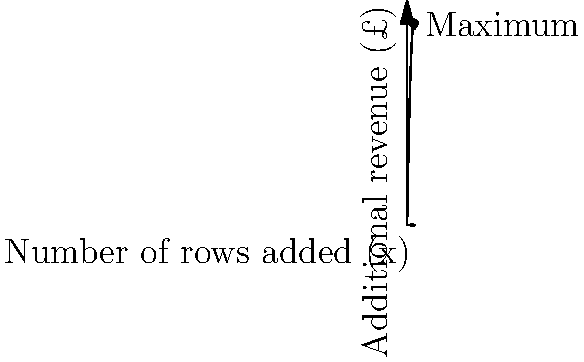Scone Thistle is planning to expand their stadium. The additional revenue (in £) generated by adding x rows of seats can be modeled by the function $R(x) = -0.5x^2 + 60x$. How many rows should be added to maximize the additional revenue, and what is this maximum revenue? To find the maximum revenue, we need to follow these steps:

1) The function $R(x) = -0.5x^2 + 60x$ is a quadratic function, which forms a parabola.

2) The maximum point of a parabola occurs at the vertex.

3) For a quadratic function in the form $f(x) = ax^2 + bx + c$, the x-coordinate of the vertex is given by $x = -\frac{b}{2a}$.

4) In our case, $a = -0.5$ and $b = 60$. So:

   $x = -\frac{60}{2(-0.5)} = -\frac{60}{-1} = 60$

5) This means the maximum occurs when 60 rows are added.

6) To find the maximum revenue, we substitute x = 60 into the original function:

   $R(60) = -0.5(60)^2 + 60(60)$
   $= -0.5(3600) + 3600$
   $= -1800 + 3600$
   $= 1800$

Therefore, the maximum additional revenue of £1800 occurs when 60 rows are added.
Answer: 60 rows; £1800 